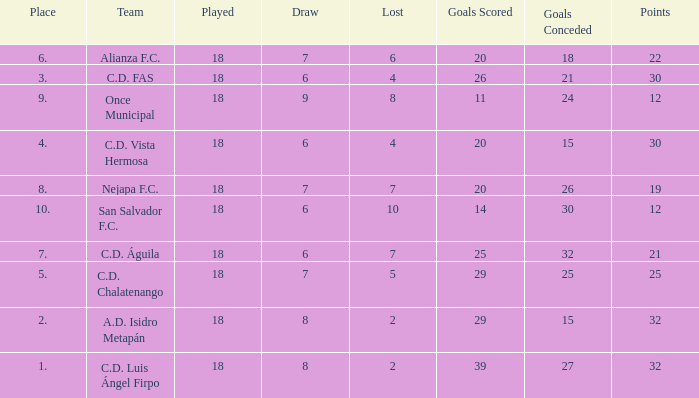What is the lowest played with a lost bigger than 10? None. 